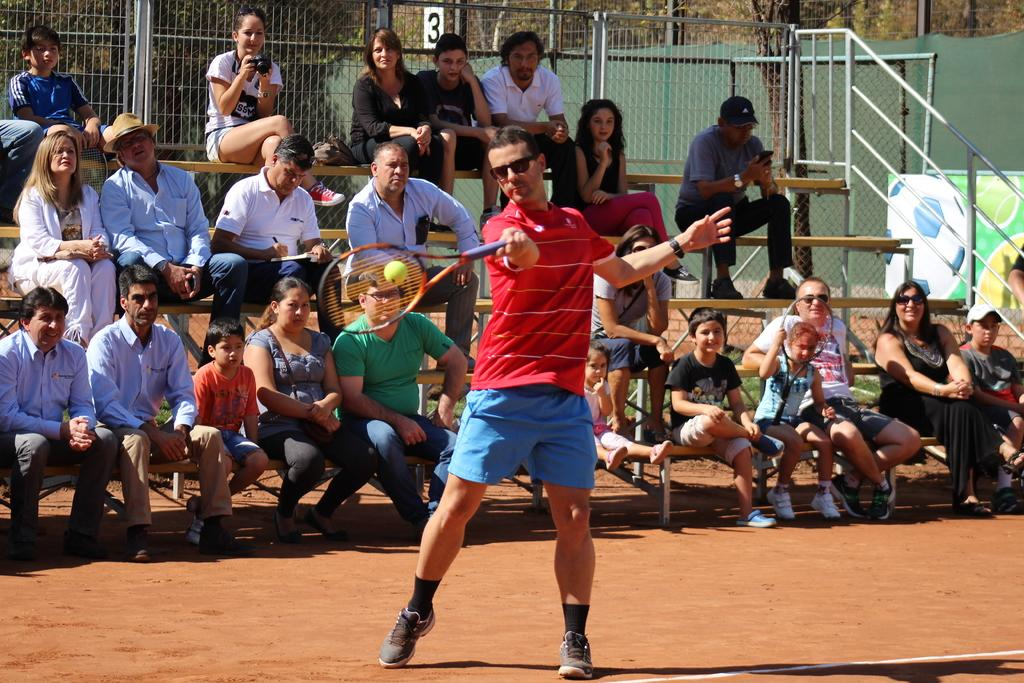Provide a one-sentence caption for the provided image. A tennis match being played with the number 3 behind people watching. 